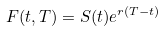Convert formula to latex. <formula><loc_0><loc_0><loc_500><loc_500>F ( t , T ) = S ( t ) e ^ { r ( T - t ) }</formula> 